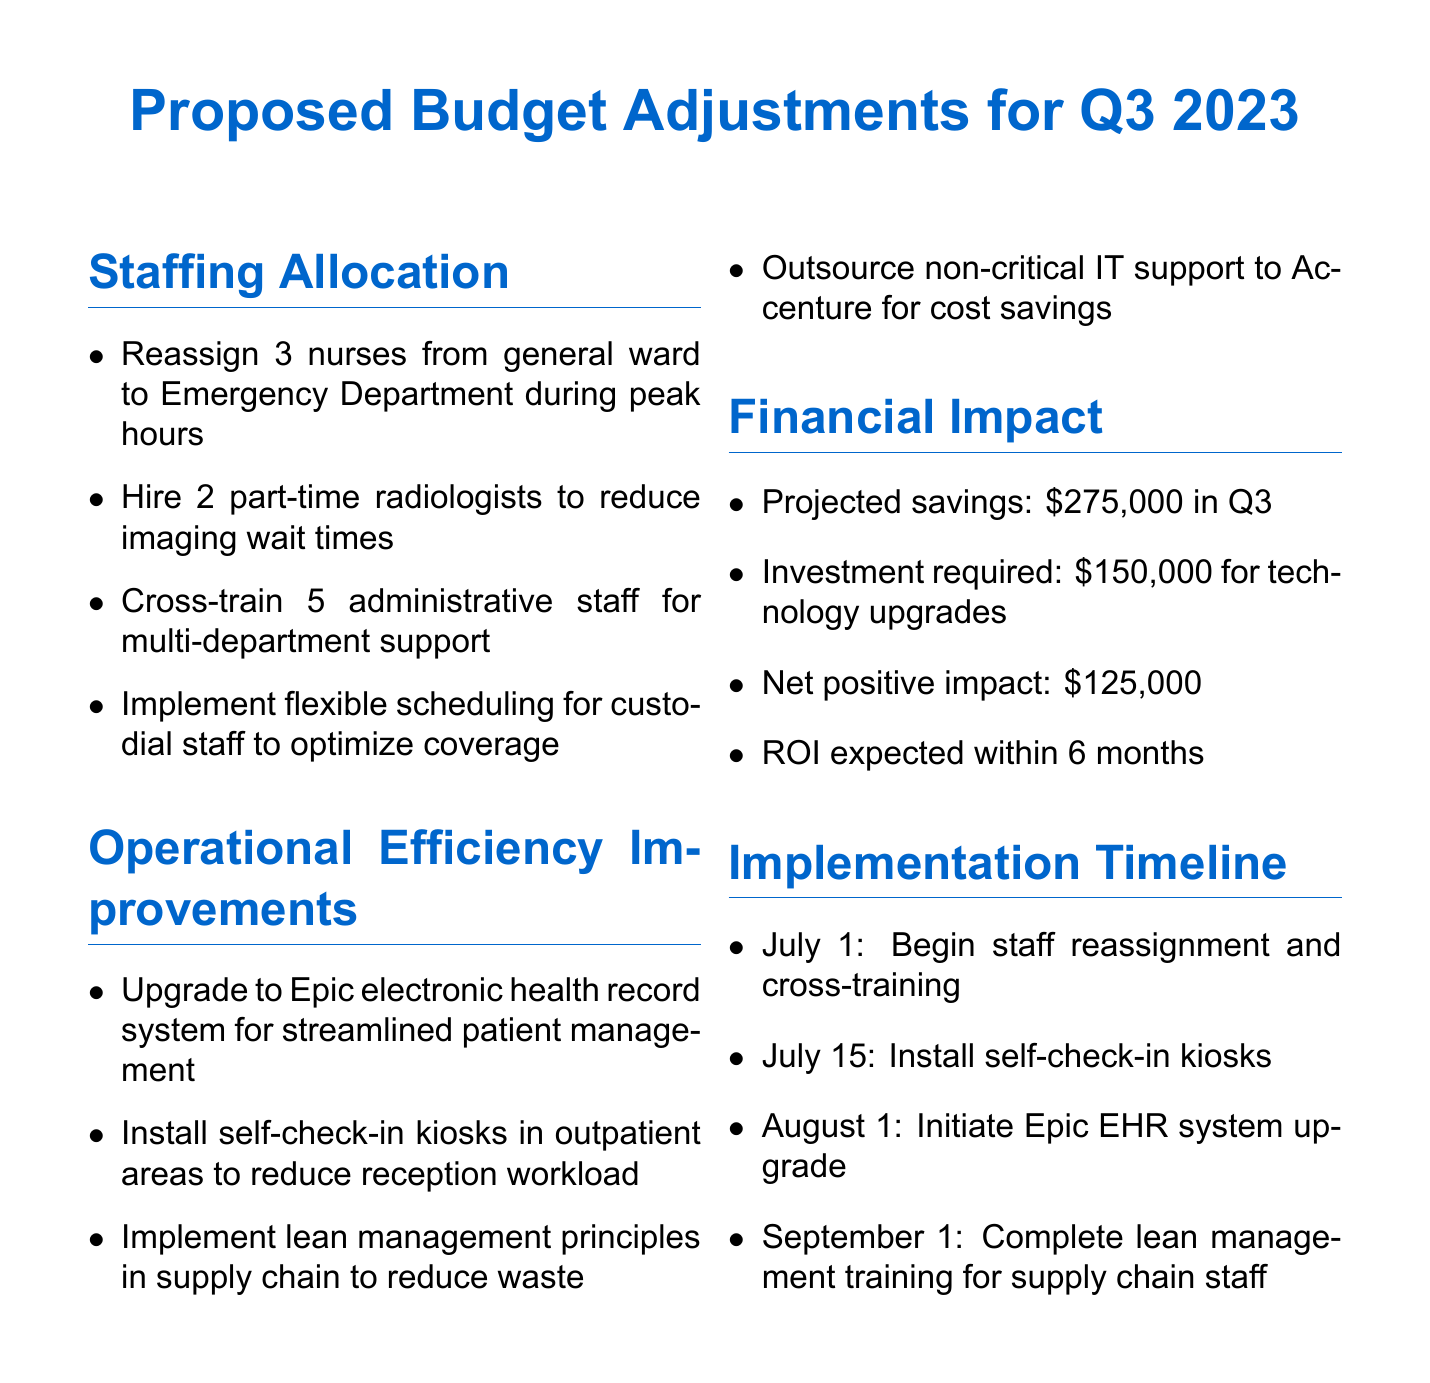What are the proposed savings for Q3? The document states that the projected savings are $275,000 in Q3.
Answer: $275,000 How many nurses will be reassigned to the Emergency Department? The document specifies that 3 nurses will be reassigned from the general ward to the Emergency Department during peak hours.
Answer: 3 nurses What investment is required for technology upgrades? The document mentions that the investment required for technology upgrades is $150,000.
Answer: $150,000 When will the self-check-in kiosks be installed? The document indicates that the installation of self-check-in kiosks is scheduled for July 15.
Answer: July 15 Which department will be affected by the cross-training of administrative staff? The document notes that 5 administrative staff will be cross-trained for multi-department support.
Answer: Multi-department What is the expected ROI period for the proposed changes? The document states that the ROI is expected within 6 months.
Answer: 6 months How many part-time radiologists does the proposal suggest hiring? The document indicates a suggestion to hire 2 part-time radiologists to reduce imaging wait times.
Answer: 2 part-time radiologists What is one method proposed to improve operational efficiency? The document outlines several methods, including an upgrade to the Epic electronic health record system for streamlined patient management.
Answer: Upgrade to Epic EHR What is the implementation date for beginning staff reassignment? The document specifies that staff reassignment and cross-training will begin on July 1.
Answer: July 1 